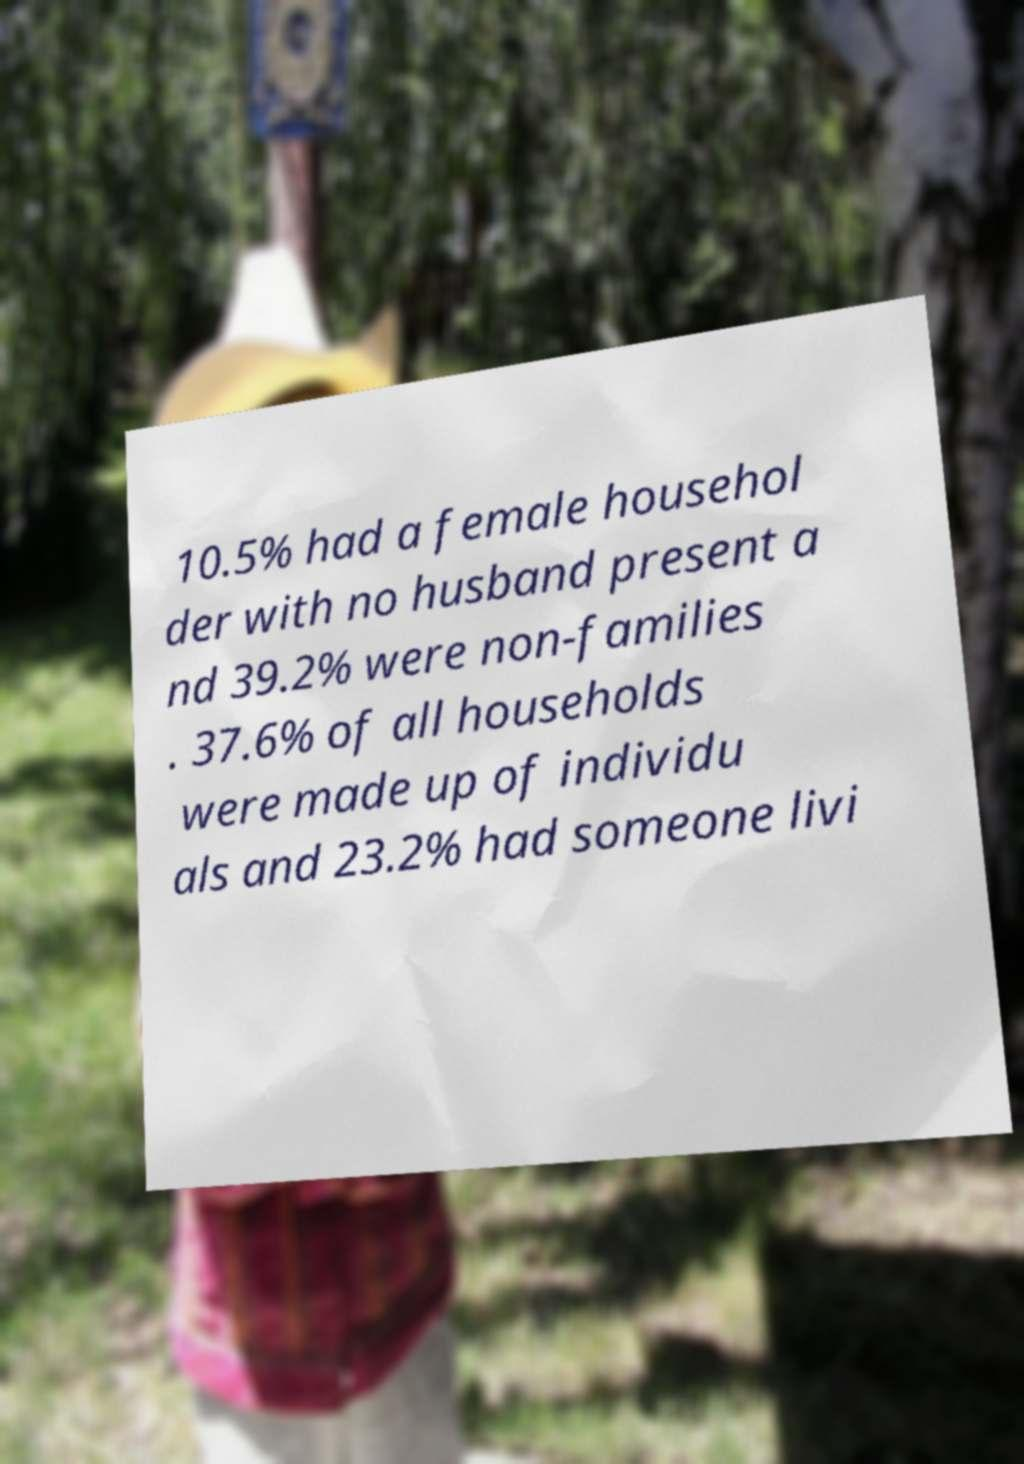Could you extract and type out the text from this image? 10.5% had a female househol der with no husband present a nd 39.2% were non-families . 37.6% of all households were made up of individu als and 23.2% had someone livi 